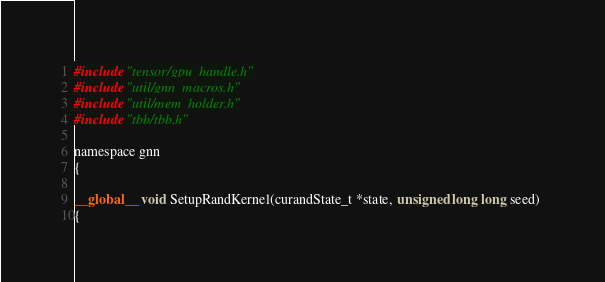Convert code to text. <code><loc_0><loc_0><loc_500><loc_500><_Cuda_>#include "tensor/gpu_handle.h"
#include "util/gnn_macros.h"
#include "util/mem_holder.h"
#include "tbb/tbb.h"

namespace gnn
{

__global__ void SetupRandKernel(curandState_t *state, unsigned long long seed) 
{</code> 